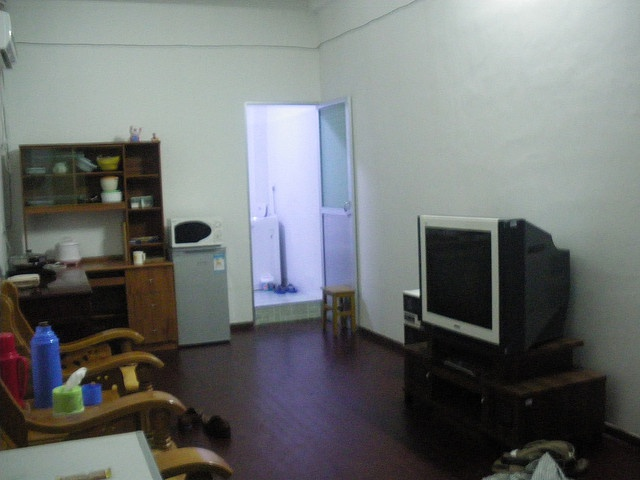Describe the objects in this image and their specific colors. I can see tv in gray, black, and darkgray tones, chair in gray, black, olive, maroon, and navy tones, refrigerator in gray, black, and darkgray tones, chair in gray, black, maroon, and olive tones, and bottle in gray, navy, blue, black, and darkblue tones in this image. 